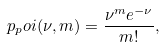<formula> <loc_0><loc_0><loc_500><loc_500>p _ { p } o i ( \nu , m ) = \frac { \nu ^ { m } e ^ { - \nu } } { m ! } ,</formula> 